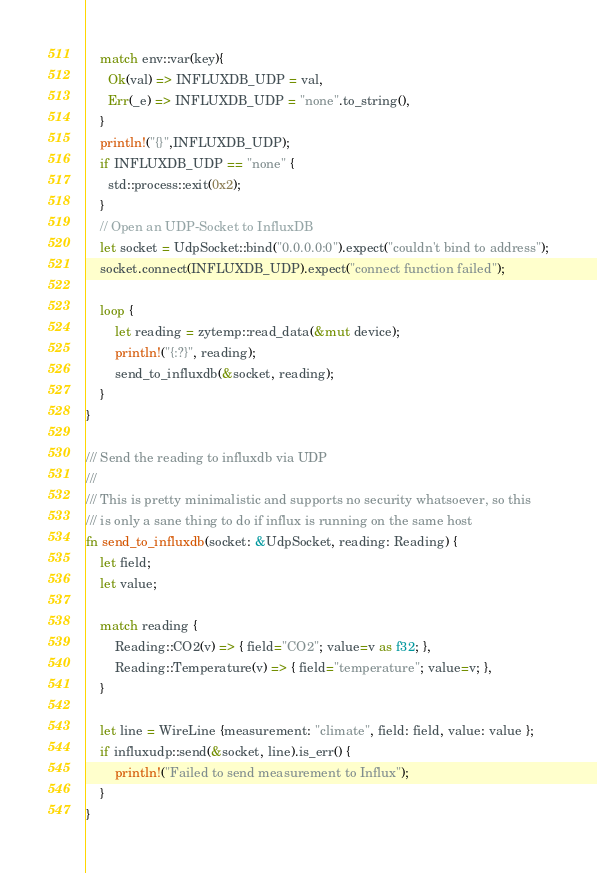<code> <loc_0><loc_0><loc_500><loc_500><_Rust_>
    match env::var(key){
      Ok(val) => INFLUXDB_UDP = val,
      Err(_e) => INFLUXDB_UDP = "none".to_string(),
    }
    println!("{}",INFLUXDB_UDP);
    if INFLUXDB_UDP == "none" { 
      std::process::exit(0x2);
    }
    // Open an UDP-Socket to InfluxDB
    let socket = UdpSocket::bind("0.0.0.0:0").expect("couldn't bind to address");
    socket.connect(INFLUXDB_UDP).expect("connect function failed");

    loop {
        let reading = zytemp::read_data(&mut device);
        println!("{:?}", reading);
        send_to_influxdb(&socket, reading);
    }
}

/// Send the reading to influxdb via UDP
///
/// This is pretty minimalistic and supports no security whatsoever, so this
/// is only a sane thing to do if influx is running on the same host 
fn send_to_influxdb(socket: &UdpSocket, reading: Reading) {
    let field;
    let value;

    match reading {
        Reading::CO2(v) => { field="CO2"; value=v as f32; },
        Reading::Temperature(v) => { field="temperature"; value=v; },
    }

    let line = WireLine {measurement: "climate", field: field, value: value };
    if influxudp::send(&socket, line).is_err() {
        println!("Failed to send measurement to Influx");
    }
}
</code> 